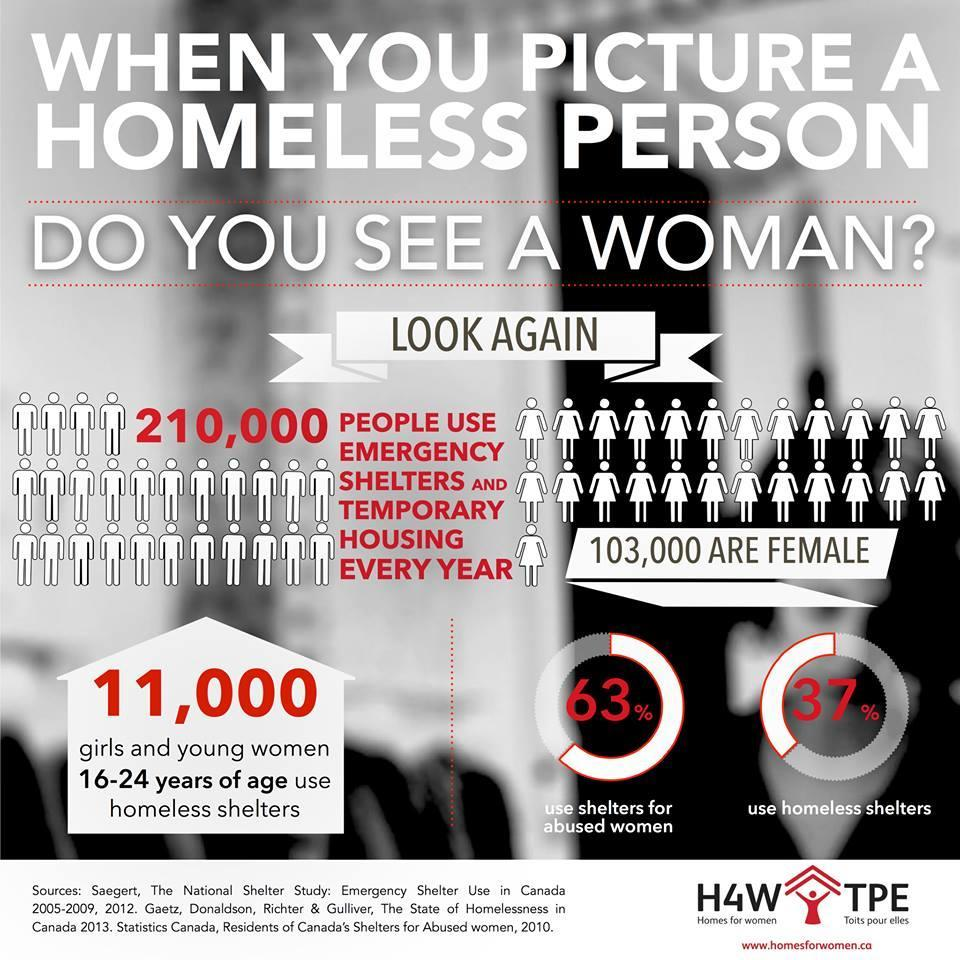How many girls & young women aged 16-24 years use homeless shelters in Canada?
Answer the question with a short phrase. 11,000 What percentage of people in Canada use homeless shelters? 37% 